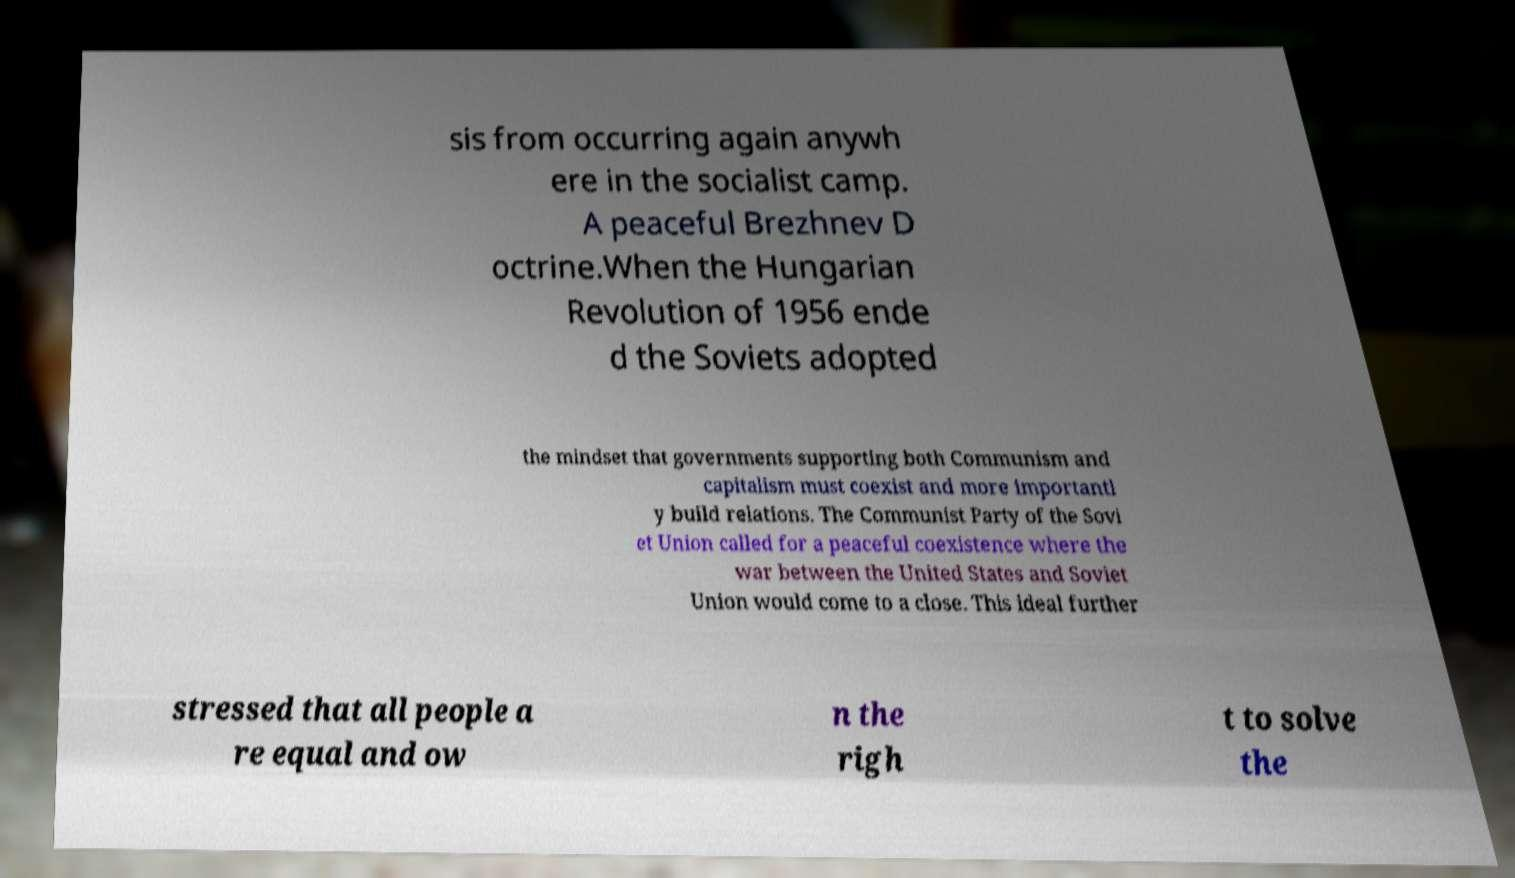Can you accurately transcribe the text from the provided image for me? sis from occurring again anywh ere in the socialist camp. A peaceful Brezhnev D octrine.When the Hungarian Revolution of 1956 ende d the Soviets adopted the mindset that governments supporting both Communism and capitalism must coexist and more importantl y build relations. The Communist Party of the Sovi et Union called for a peaceful coexistence where the war between the United States and Soviet Union would come to a close. This ideal further stressed that all people a re equal and ow n the righ t to solve the 